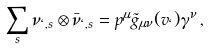Convert formula to latex. <formula><loc_0><loc_0><loc_500><loc_500>\sum _ { s } \nu _ { \ell , s } \otimes \bar { \nu } _ { \ell , s } = p ^ { \mu } { \tilde { g } } _ { \mu \nu } ( v _ { \ell } ) \gamma ^ { \nu } \, ,</formula> 